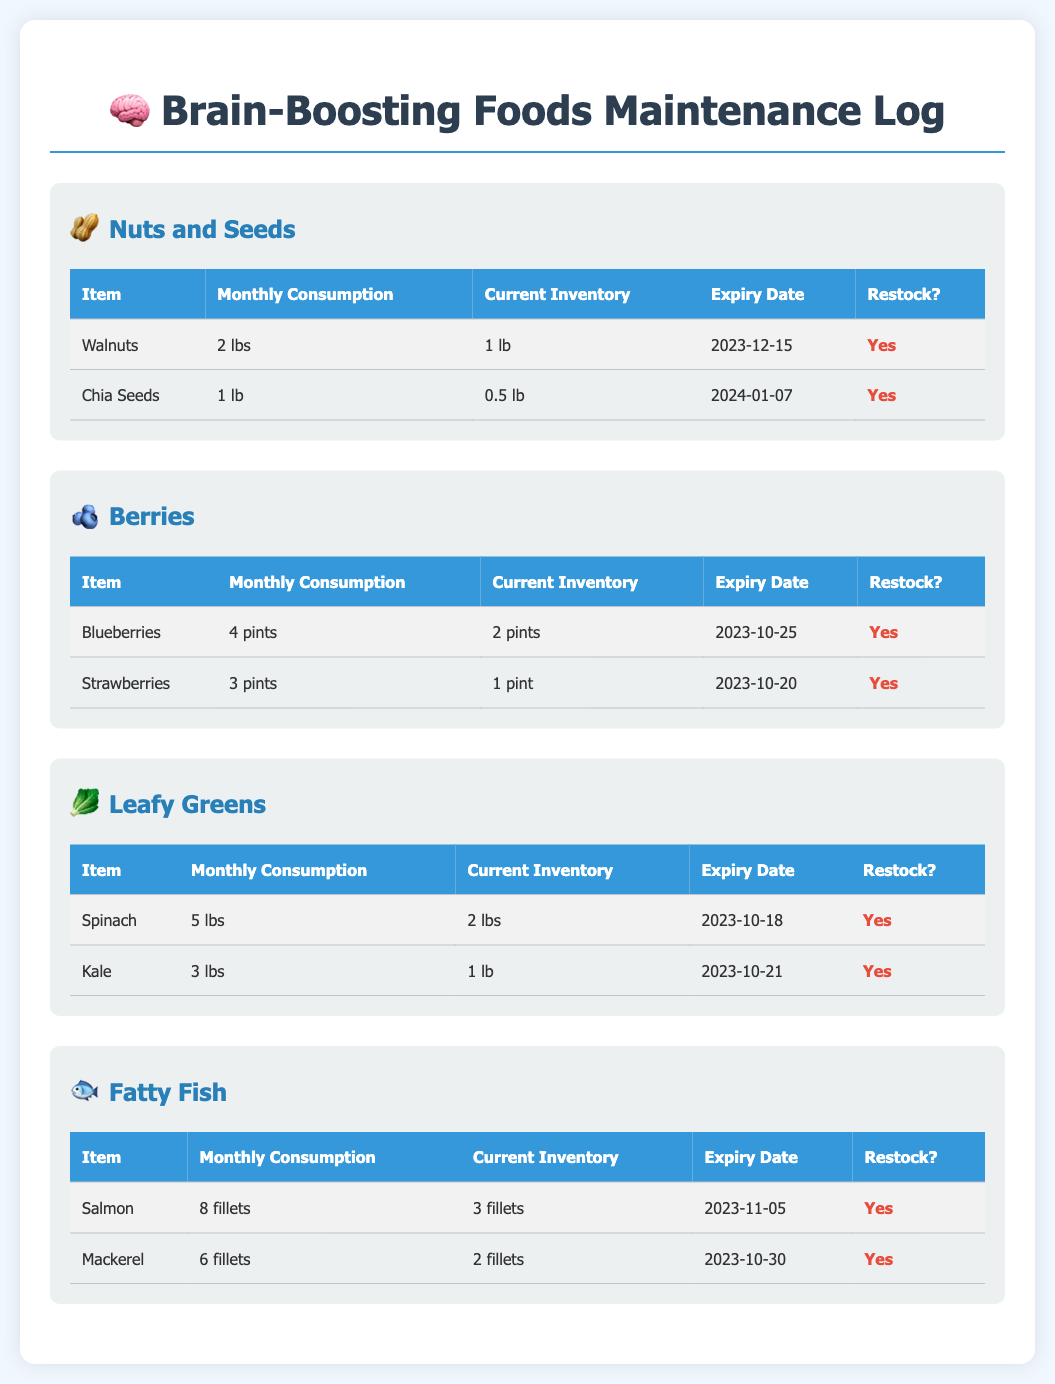What is the current inventory of walnuts? The current inventory of walnuts as listed in the document is 1 lb.
Answer: 1 lb How many pounds of spinach were consumed this month? The document states that 5 lbs of spinach were consumed this month.
Answer: 5 lbs What is the expiry date of chia seeds? According to the document, the expiry date of chia seeds is 2024-01-07.
Answer: 2024-01-07 How many pints of blueberries need to be restocked? The current inventory of blueberries is 2 pints, while the monthly consumption is 4 pints, indicating a shortage.
Answer: Yes Which food item has the earliest expiry date? The earliest expiry date in the document is for strawberries, which is 2023-10-20.
Answer: Strawberries 